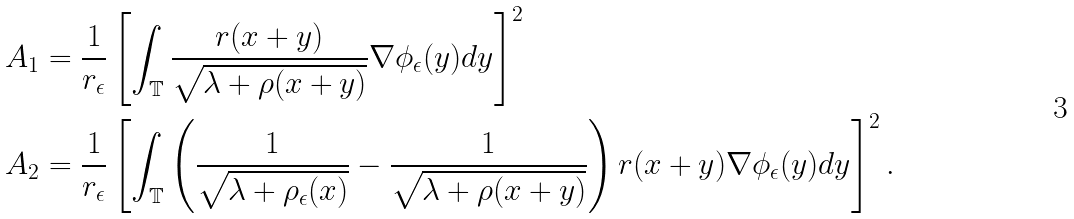<formula> <loc_0><loc_0><loc_500><loc_500>A _ { 1 } & = \frac { 1 } { r _ { \epsilon } } \left [ \int _ { \mathbb { T } } \frac { r ( x + y ) } { \sqrt { \lambda + \rho ( x + y ) } } \nabla \phi _ { \epsilon } ( y ) d y \right ] ^ { 2 } \\ A _ { 2 } & = \frac { 1 } { r _ { \epsilon } } \left [ \int _ { \mathbb { T } } \left ( \frac { 1 } { \sqrt { \lambda + \rho _ { \epsilon } ( x ) } } - \frac { 1 } { \sqrt { \lambda + \rho ( x + y ) } } \right ) r ( x + y ) \nabla \phi _ { \epsilon } ( y ) d y \right ] ^ { 2 } .</formula> 